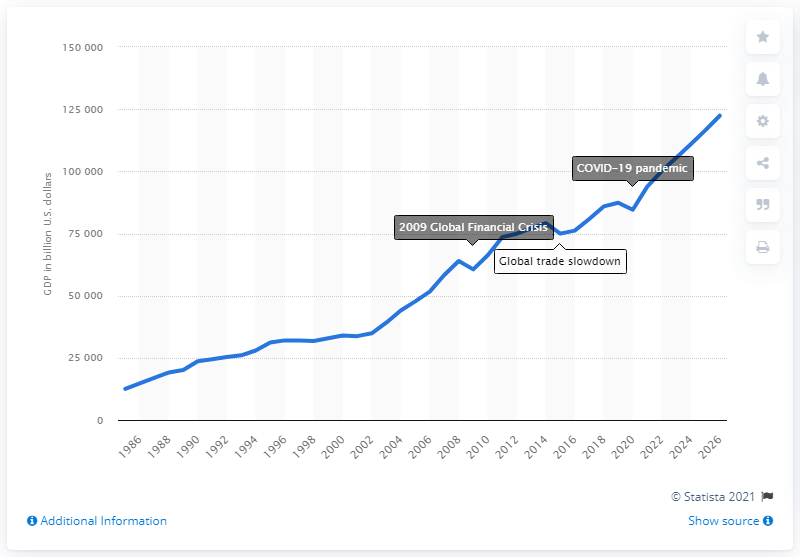Point out several critical features in this image. In 2020, the global Gross Domestic Product (GDP) was estimated to be 84,537.69 billion dollars. In 2020, the global Gross Domestic Product (GDP) was significantly lower than it was in 2019, at 845,376.90. 